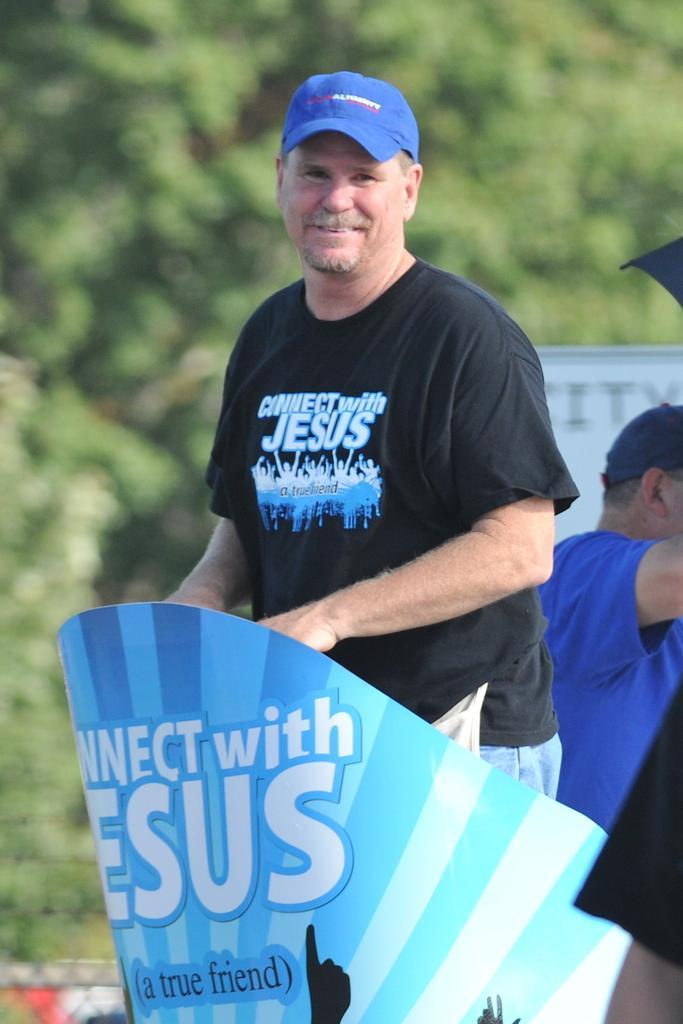Please provide a concise description of this image. In this image there is a person standing with a smiling face, behind the person there is another person, in the background of the image there are trees. 